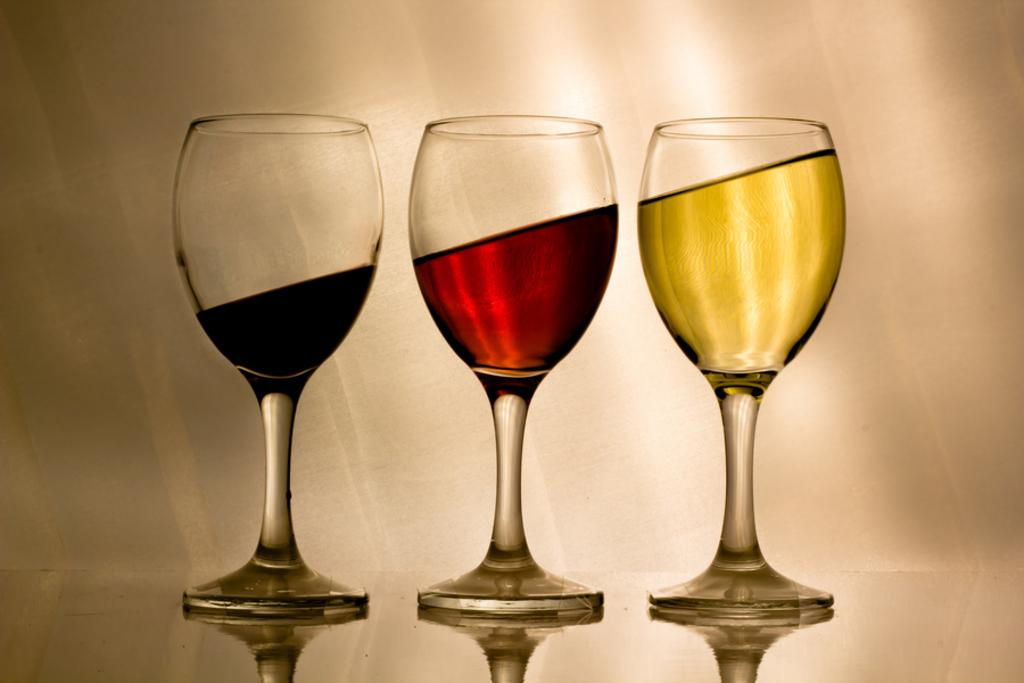How many glasses are visible in the image? There are three glasses in the image. What is inside each of the glasses? Each glass contains a drink. Can you describe the appearance of the drinks in the glasses? The drinks in the glasses are of different colors. Where is the guitar placed in the image? There is no guitar present in the image. What type of place is depicted in the image? The image does not depict a specific place; it only shows three glasses with different colored drinks. Can you see a chessboard or chess pieces in the image? There is no chessboard or chess pieces present in the image. 